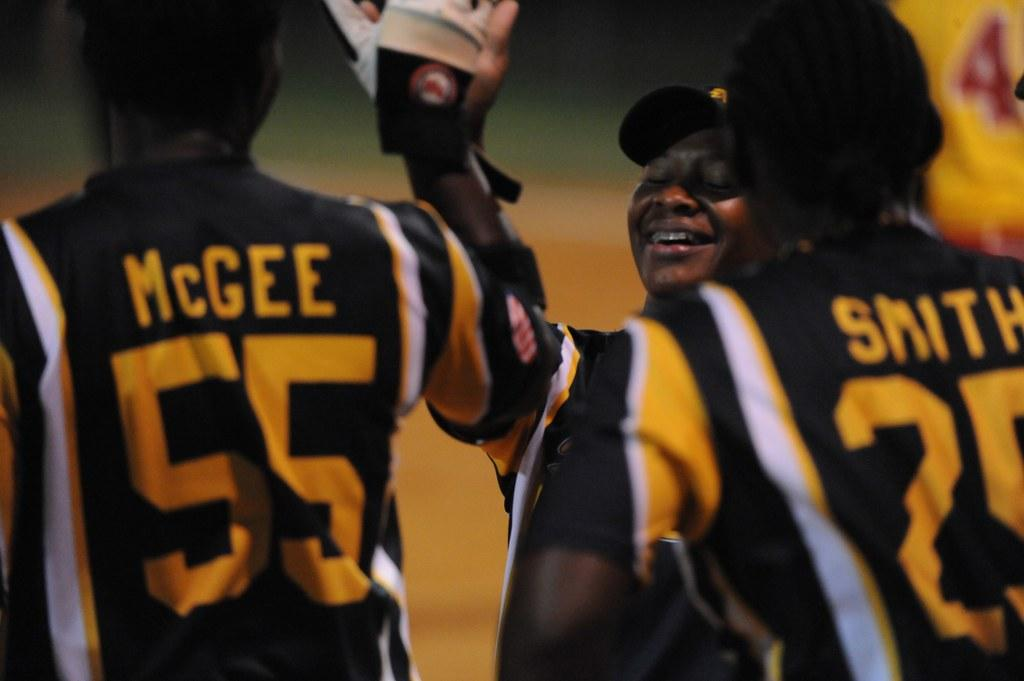Where was the image taken? The image is taken outdoors. What can be seen in the background of the image? There is a ground visible in the background. How many men are in the image? There are a few men in the middle of the image. What are the men wearing on their upper bodies? The men are wearing T-shirts with text on them. What type of underwear can be seen on the men in the image? There is no underwear visible on the men in the image; they are wearing T-shirts. What skin condition can be observed on the men in the image? There is no mention of any skin condition in the image; the men are wearing T-shirts. 